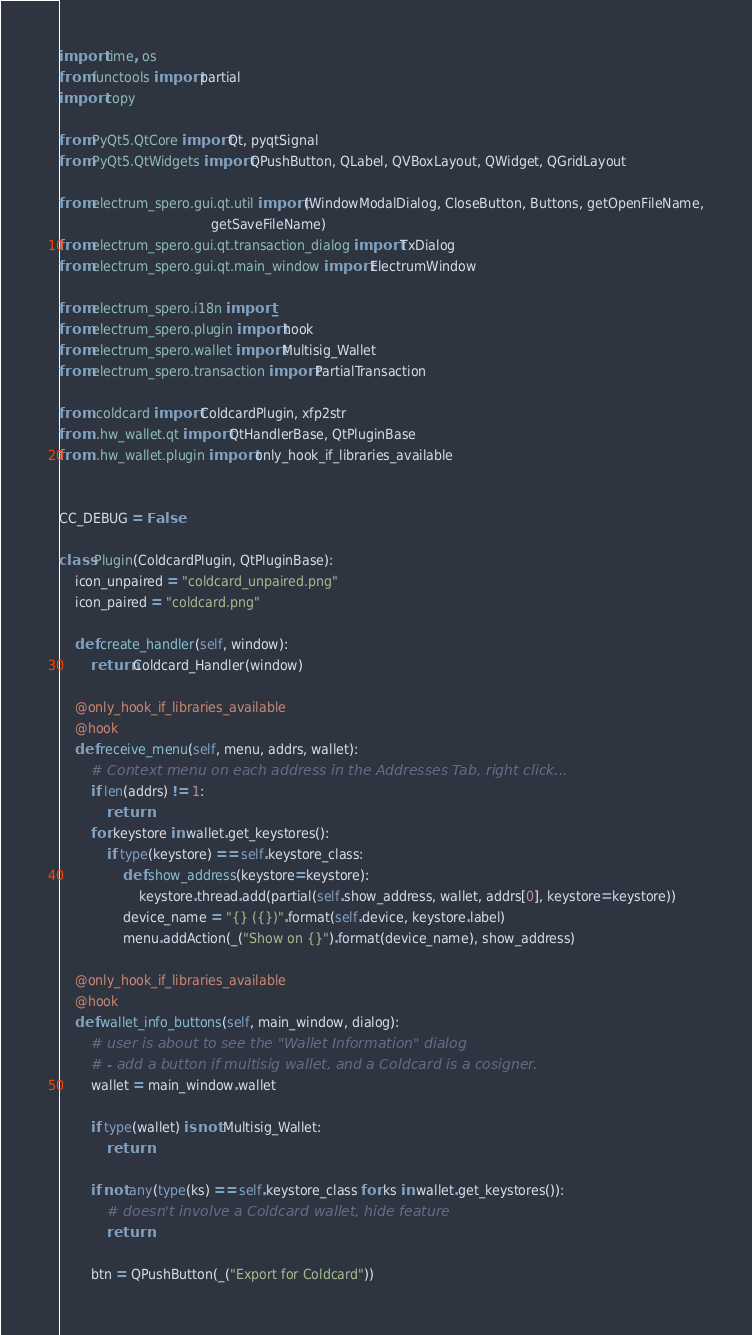<code> <loc_0><loc_0><loc_500><loc_500><_Python_>import time, os
from functools import partial
import copy

from PyQt5.QtCore import Qt, pyqtSignal
from PyQt5.QtWidgets import QPushButton, QLabel, QVBoxLayout, QWidget, QGridLayout

from electrum_spero.gui.qt.util import (WindowModalDialog, CloseButton, Buttons, getOpenFileName,
                                      getSaveFileName)
from electrum_spero.gui.qt.transaction_dialog import TxDialog
from electrum_spero.gui.qt.main_window import ElectrumWindow

from electrum_spero.i18n import _
from electrum_spero.plugin import hook
from electrum_spero.wallet import Multisig_Wallet
from electrum_spero.transaction import PartialTransaction

from .coldcard import ColdcardPlugin, xfp2str
from ..hw_wallet.qt import QtHandlerBase, QtPluginBase
from ..hw_wallet.plugin import only_hook_if_libraries_available


CC_DEBUG = False

class Plugin(ColdcardPlugin, QtPluginBase):
    icon_unpaired = "coldcard_unpaired.png"
    icon_paired = "coldcard.png"

    def create_handler(self, window):
        return Coldcard_Handler(window)

    @only_hook_if_libraries_available
    @hook
    def receive_menu(self, menu, addrs, wallet):
        # Context menu on each address in the Addresses Tab, right click...
        if len(addrs) != 1:
            return
        for keystore in wallet.get_keystores():
            if type(keystore) == self.keystore_class:
                def show_address(keystore=keystore):
                    keystore.thread.add(partial(self.show_address, wallet, addrs[0], keystore=keystore))
                device_name = "{} ({})".format(self.device, keystore.label)
                menu.addAction(_("Show on {}").format(device_name), show_address)

    @only_hook_if_libraries_available
    @hook
    def wallet_info_buttons(self, main_window, dialog):
        # user is about to see the "Wallet Information" dialog
        # - add a button if multisig wallet, and a Coldcard is a cosigner.
        wallet = main_window.wallet

        if type(wallet) is not Multisig_Wallet:
            return

        if not any(type(ks) == self.keystore_class for ks in wallet.get_keystores()):
            # doesn't involve a Coldcard wallet, hide feature
            return

        btn = QPushButton(_("Export for Coldcard"))</code> 